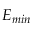<formula> <loc_0><loc_0><loc_500><loc_500>E _ { \min }</formula> 